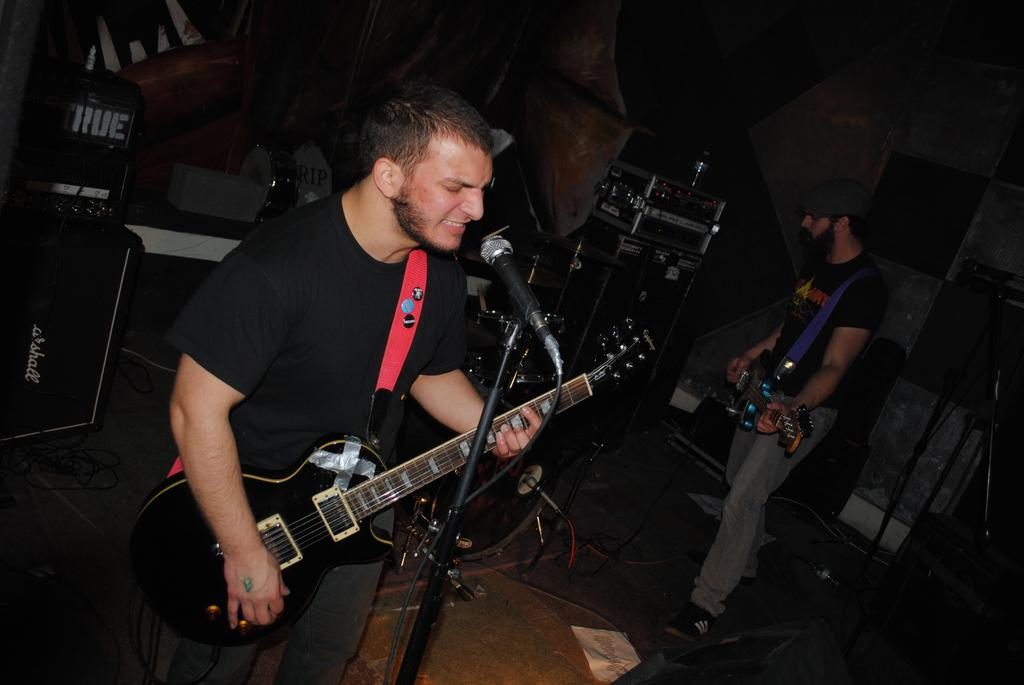What is the man in the image doing? The man is singing in the image. What is the man holding while singing? The man is holding a microphone. What musical instrument is the man playing? The man is playing a guitar. What type of surface is visible in the image? The image shows a floor. How many men holding guitars are in the image? There is one man holding a guitar in the image. What other objects related to music can be seen in the image? There are musical instruments in the image. What type of background is present in the image? There is a wall in the image. What type of plant is growing on the man's head in the image? There is no plant growing on the man's head in the image. What kind of breakfast is the man eating while playing the guitar? The image does not show the man eating any breakfast; he is only playing the guitar and singing. 